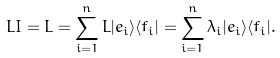Convert formula to latex. <formula><loc_0><loc_0><loc_500><loc_500>L I = L = \sum _ { i = 1 } ^ { n } L | e _ { i } \rangle \langle f _ { i } | = \sum _ { i = 1 } ^ { n } \lambda _ { i } | e _ { i } \rangle \langle f _ { i } | .</formula> 